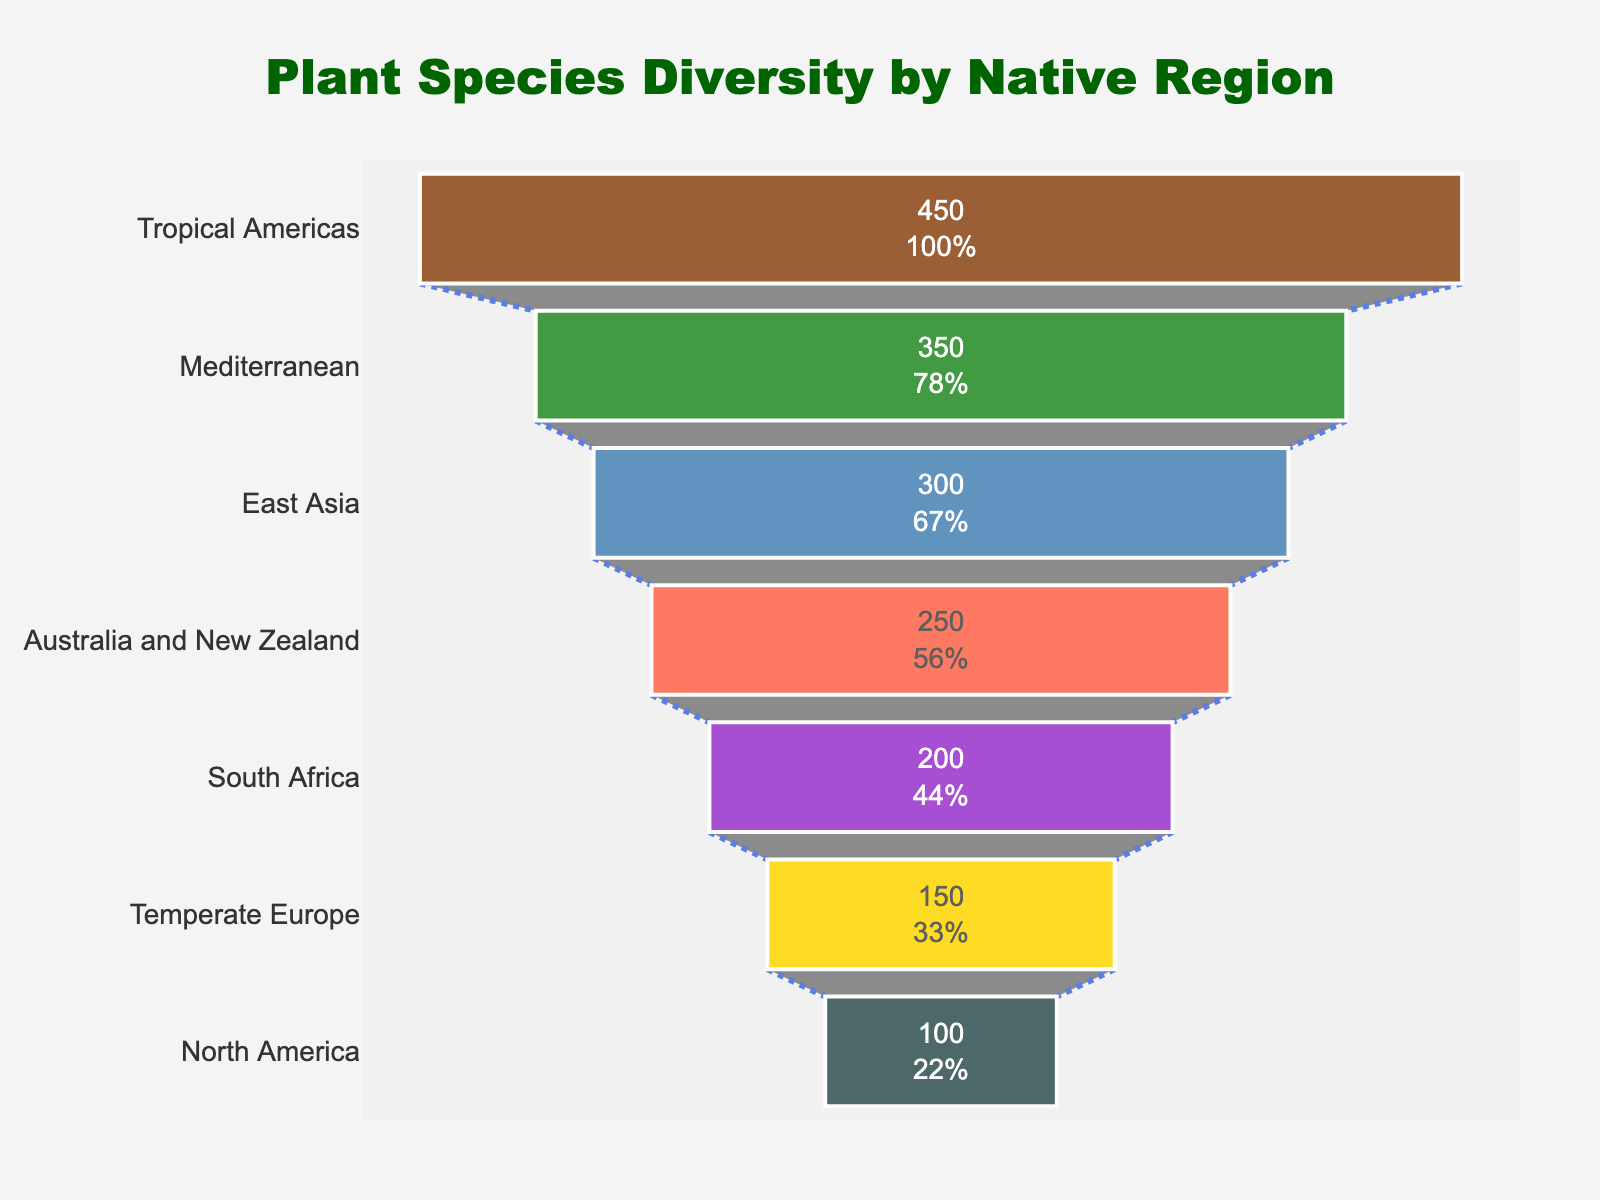Which region has the highest plant species count? The region with the highest plant species count is identified by looking at the widest bar at the top of the funnel chart.
Answer: Tropical Americas How many plant species are found in the Mediterranean region? The Mediterranean region is the second bar from the top on the funnel chart. Reading the value inside the bar shows the species count.
Answer: 350 What is the total species count for East Asia and Australia and New Zealand combined? Sum the species counts for East Asia and Australia and New Zealand, which are 300 and 250, respectively. 300 + 250 = 550
Answer: 550 Which regions have a species count less than 200? Identify the bars on the funnel chart with species counts less than 200. Both Temperate Europe and North America have species counts of 150 and 100, respectively.
Answer: Temperate Europe, North America How much larger is the species count of Tropical Americas compared to North America? Calculate the difference between the species counts of Tropical Americas (450) and North America (100). 450 - 100 = 350
Answer: 350 What percentage of the total species count are found in the top three regions? First, calculate the total species count for all regions, which is 450 + 350 + 300 + 250 + 200 + 150 + 100 = 1800. Then, sum the species counts for the top three regions (450 + 350 + 300 = 1100) and divide by the total. (1100 / 1800) * 100 ≈ 61.1%
Answer: 61.1% Rank the regions from highest to lowest species count. List the regions in order based on the visual width of their bars from top to bottom on the funnel chart.
Answer: Tropical Americas, Mediterranean, East Asia, Australia and New Zealand, South Africa, Temperate Europe, North America What is the difference in species count between South Africa and North America? Subtract the species count of North America (100) from South Africa (200). 200 - 100 = 100
Answer: 100 Which region has approximately one-fourth of the species count of Tropical Americas? Find the region where the species count is about one-fourth of 450 (which is 112.5). North America's count of 100 is closest.
Answer: North America Is the combined species count of South Africa, Temperate Europe, and North America greater than that of Tropical Americas and Mediterranean combined? Calculate the combined counts for both sets: South Africa, Temperate Europe, North America (200 + 150 + 100 = 450); Tropical Americas and Mediterranean (450 + 350 = 800). Compare the sums (450 < 800).
Answer: No 